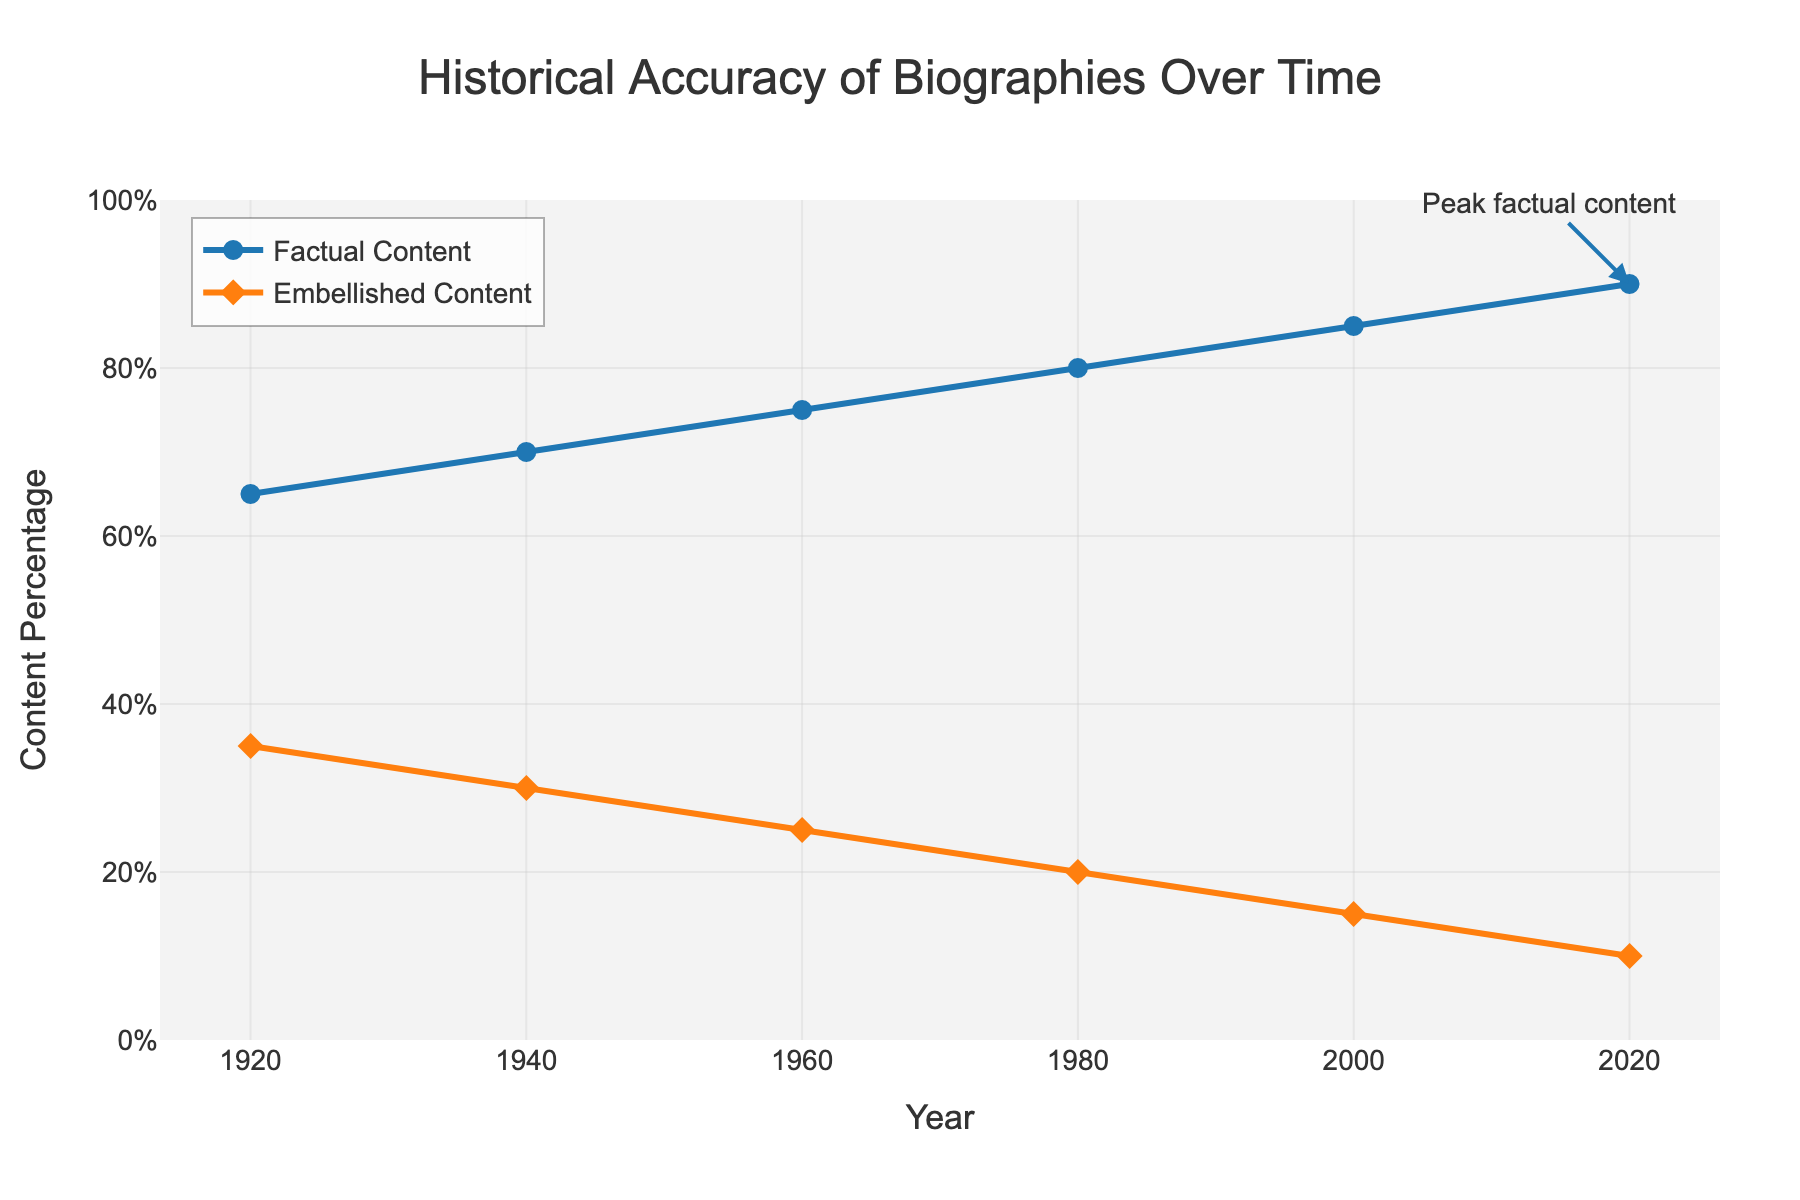What's the overall trend in factual content from 1920 to 2020? From the figure, observe the line representing the factual content percentage from 1920 to 2020. The line shows an upward trend, indicating an increase in factual content over the years.
Answer: An upward trend How does the embellished content in 1940 compare to that in 1980? Look at the values on the line representing embellished content. In 1940, the embellished content is at 30%, and by 1980, it has decreased to 20%.
Answer: Decreases by 10% What's the difference between factual and embellished content in 2020? In 2020, the factual content is at 90%, and the embellished content is at 10%. The difference between these two percentages is 90% - 10% = 80%.
Answer: 80% What is the average embellished content for the years 1920, 1940, and 1960? Calculate the average of the embellished content values for 1920 (35%), 1940 (30%), and 1960 (25%). The sum is 35 + 30 + 25 = 90, and the average is 90 / 3 = 30%.
Answer: 30% At what point does factual content surpass 75%? Look at the factual content line over the years. In 1960, the factual content reaches 75%. Therefore, it surpasses 75% after 1960.
Answer: After 1960 Which year marks the peak of factual content as annotated in the figure? The annotation in the figure indicates that the peak factual content is marked in the year 2020.
Answer: 2020 How does the factual content in 1960 compare to the embellished content in 2000? In 1960, the factual content is at 75%. In 2000, the embellished content is at 15%. Compare these values directly; the factual content in 1960 is higher than the embellished content in 2000.
Answer: Higher What is the rate of increase in factual content from 1920 to 1940? The factual content in 1920 is 65%, and in 1940 it is 70%. The increase is 70% - 65% = 5%. Over 20 years, the rate of increase is 5% / 20 years = 0.25% per year.
Answer: 0.25% per year What is the visual difference in marker types between the factual and embellished content lines? The figure shows that the factual content uses circle markers, while the embellished content uses diamond markers.
Answer: Circle vs. Diamond 